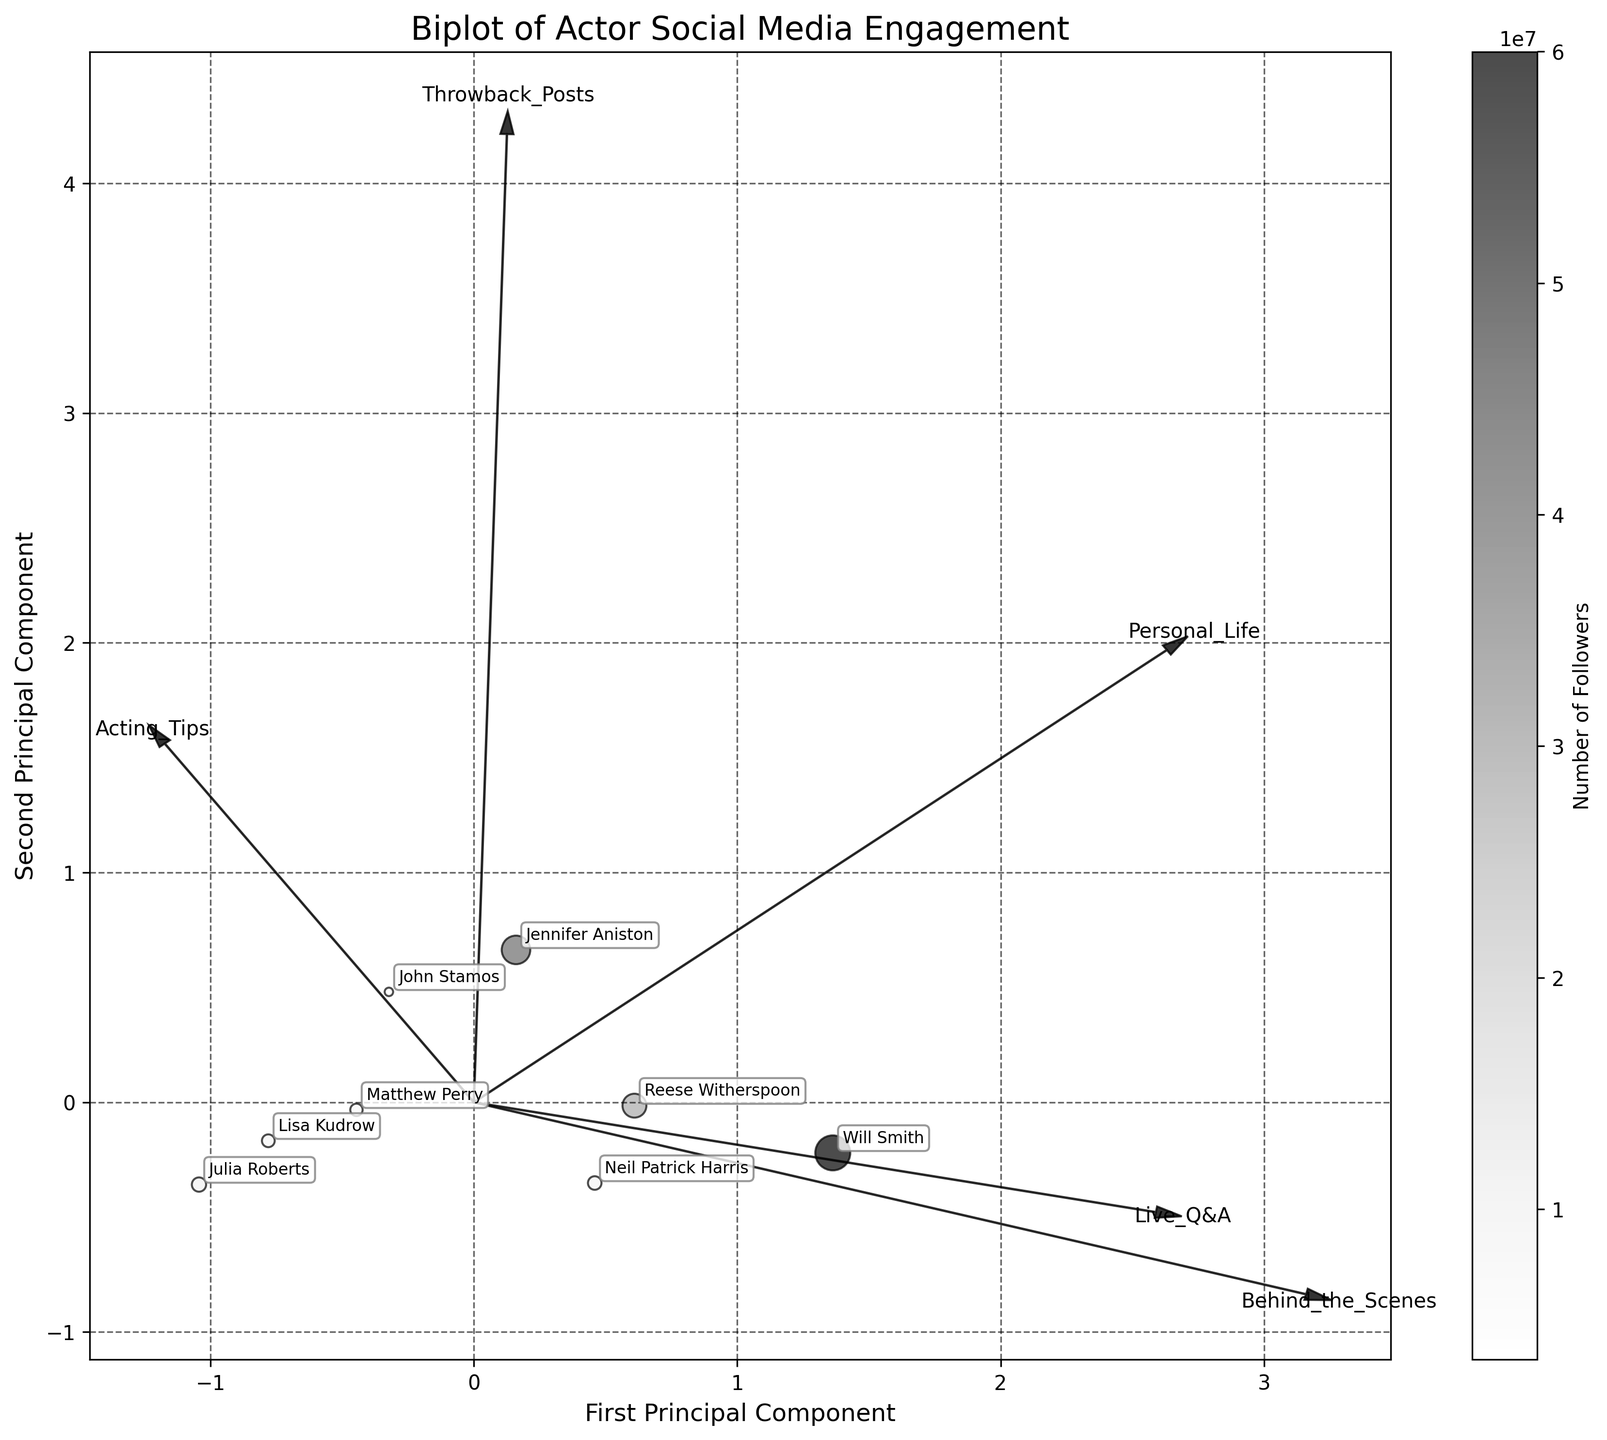What is the title of the plot? The title of the plot can typically be found at the top of the figure and is clearly written to describe what the figure represents. In this case, the title is related to social media engagement of actors.
Answer: Biplot of Actor Social Media Engagement How many different types of content are featured in the plot? The types of content are represented as vectors/ arrows labeled with the content names. By counting these labels, we can determine the number of content types.
Answer: Six Which actor has the largest number of followers? The scatter plot uses the size of the points to indicate the number of followers. Observing the largest point can help identify the actor with the most followers.
Answer: Will Smith What do the x and y axes represent in this biplot? The axes in a biplot represent the principal components derived from PCA. The labels at the ends of the axes usually specify what each principal component represents.
Answer: First Principal Component and Second Principal Component Which type of content has the highest correlation with the first principal component? By looking at the vectors/arrows, the direction and length of the arrow with the highest correlation with the first principal component (x-axis) need to be identified.
Answer: Acting Tips What is the engagement trend for 'Behind the Scenes' content based on its vector direction? The direction of the 'Behind the Scenes' vector in relation to the principal components can show its trend. If the vector points towards the same direction as high values on the first principal component, it indicates high engagement with 'Behind the Scenes' content.
Answer: Positive correlation with the first principal component Compare the engagement rates between 'Personal Life' and 'Throwback Posts' for Jennifer Aniston. From the position of Jennifer Aniston on the plot and the direction of the vectors labeled 'Personal Life' and 'Throwback Posts,' observe her alignment. This indicates how she engages with each content type.
Answer: Higher for 'Personal Life' Which type of content is least correlated with the second principal component? Examine the length and direction of vectors in relation to the second principal component (y-axis). The content type with the shortest arrow or the least alignment shows the smallest correlation.
Answer: Throwback Posts Which actor is associated most closely with 'Live Q&A' content? Determine the actor whose data point is most aligned along the vector direction of 'Live Q&A'. The closest alignment indicates closest association.
Answer: Jennifer Aniston What does the color gradient in the plot indicate? The color gradient typically represents a quantitative variable in the plot. Here, it is likely linked to a specific characteristic (e.g., number of followers) which can be verified by the colorbar label.
Answer: Number of Followers 